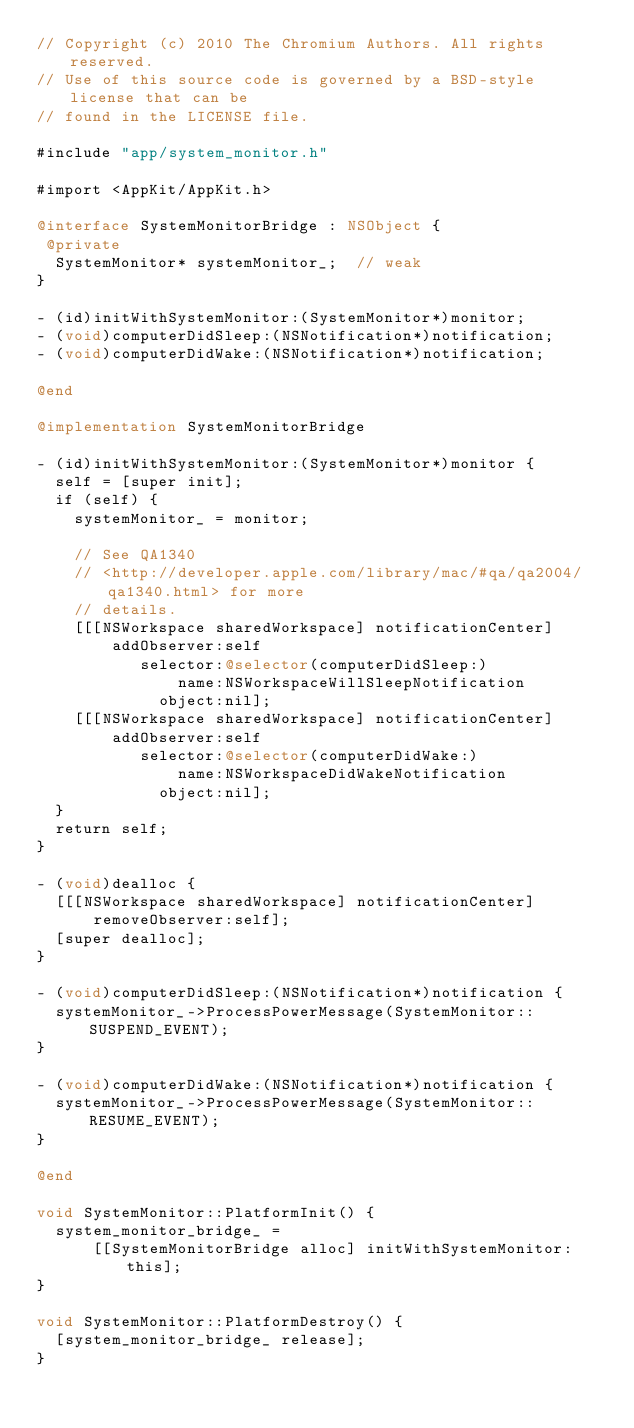Convert code to text. <code><loc_0><loc_0><loc_500><loc_500><_ObjectiveC_>// Copyright (c) 2010 The Chromium Authors. All rights reserved.
// Use of this source code is governed by a BSD-style license that can be
// found in the LICENSE file.

#include "app/system_monitor.h"

#import <AppKit/AppKit.h>

@interface SystemMonitorBridge : NSObject {
 @private
  SystemMonitor* systemMonitor_;  // weak
}

- (id)initWithSystemMonitor:(SystemMonitor*)monitor;
- (void)computerDidSleep:(NSNotification*)notification;
- (void)computerDidWake:(NSNotification*)notification;

@end

@implementation SystemMonitorBridge

- (id)initWithSystemMonitor:(SystemMonitor*)monitor {
  self = [super init];
  if (self) {
    systemMonitor_ = monitor;

    // See QA1340
    // <http://developer.apple.com/library/mac/#qa/qa2004/qa1340.html> for more
    // details.
    [[[NSWorkspace sharedWorkspace] notificationCenter]
        addObserver:self
           selector:@selector(computerDidSleep:)
               name:NSWorkspaceWillSleepNotification
             object:nil];
    [[[NSWorkspace sharedWorkspace] notificationCenter]
        addObserver:self
           selector:@selector(computerDidWake:)
               name:NSWorkspaceDidWakeNotification
             object:nil];
  }
  return self;
}

- (void)dealloc {
  [[[NSWorkspace sharedWorkspace] notificationCenter]
      removeObserver:self];
  [super dealloc];
}

- (void)computerDidSleep:(NSNotification*)notification {
  systemMonitor_->ProcessPowerMessage(SystemMonitor::SUSPEND_EVENT);
}

- (void)computerDidWake:(NSNotification*)notification {
  systemMonitor_->ProcessPowerMessage(SystemMonitor::RESUME_EVENT);
}

@end

void SystemMonitor::PlatformInit() {
  system_monitor_bridge_ =
      [[SystemMonitorBridge alloc] initWithSystemMonitor:this];
}

void SystemMonitor::PlatformDestroy() {
  [system_monitor_bridge_ release];
}
</code> 